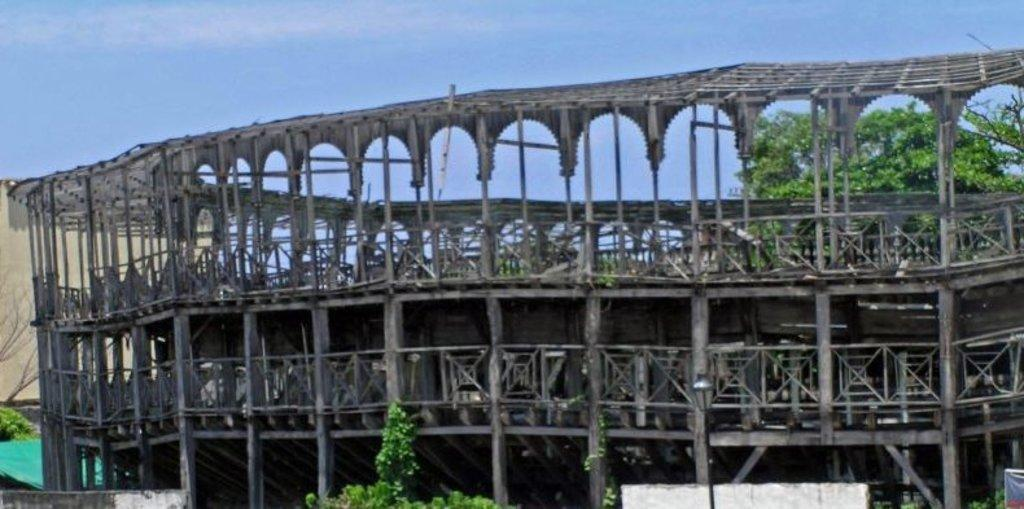What is located in the foreground of the image? There is an architecture and trees in the foreground of the image. What can be seen in the background of the image? There is a wall in the background of the image. What is visible at the top of the image? The sky is visible at the top of the image. How many roses are growing on the architecture in the image? There are no roses visible on the architecture in the image. What type of bean is being used as a construction material for the wall in the background? There is no mention of beans being used as a construction material for the wall in the image. 